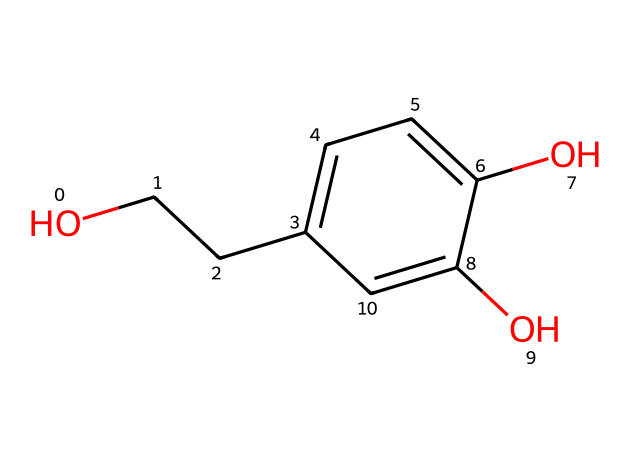What is the molecular formula of this compound? By analyzing the structure, we can count the atoms of each element present. There are 9 carbon atoms, 10 hydrogen atoms, and 4 oxygen atoms in the structure. Therefore, the molecular formula becomes C9H10O4.
Answer: C9H10O4 How many hydroxyl (–OH) groups are present in this structure? In the given SMILES representation, the presence of two 'O' atoms connected to 'H' indicates the presence of two hydroxyl groups (–OH) in the structure.
Answer: 2 What type of compound is this? The structural analysis shows the presence of multiple hydroxyl groups and a ring structure, categorizing it as a polyphenol compound, which is a known type of antioxidant.
Answer: polyphenol How many rings are present in the structure? The presence of the 'c' character in the SMILES representation indicates the presence of aromatic carbons, which form a cyclic structure. Analyzing the entire structure shows that there is one ring present.
Answer: 1 Is this compound capable of acting as an antioxidant? The presence of multiple hydroxyl groups in the structure increases the likelihood of the compound donating electrons and neutralizing free radicals, thus confirming its capability as an antioxidant.
Answer: yes What is the significance of the presence of hydroxyl groups in this compound? Hydroxyl groups enhance the compound's ability to scavenge free radicals by donating hydrogen atoms, which is a key mechanism for antioxidants to protect cells from oxidative damage.
Answer: cell protection 